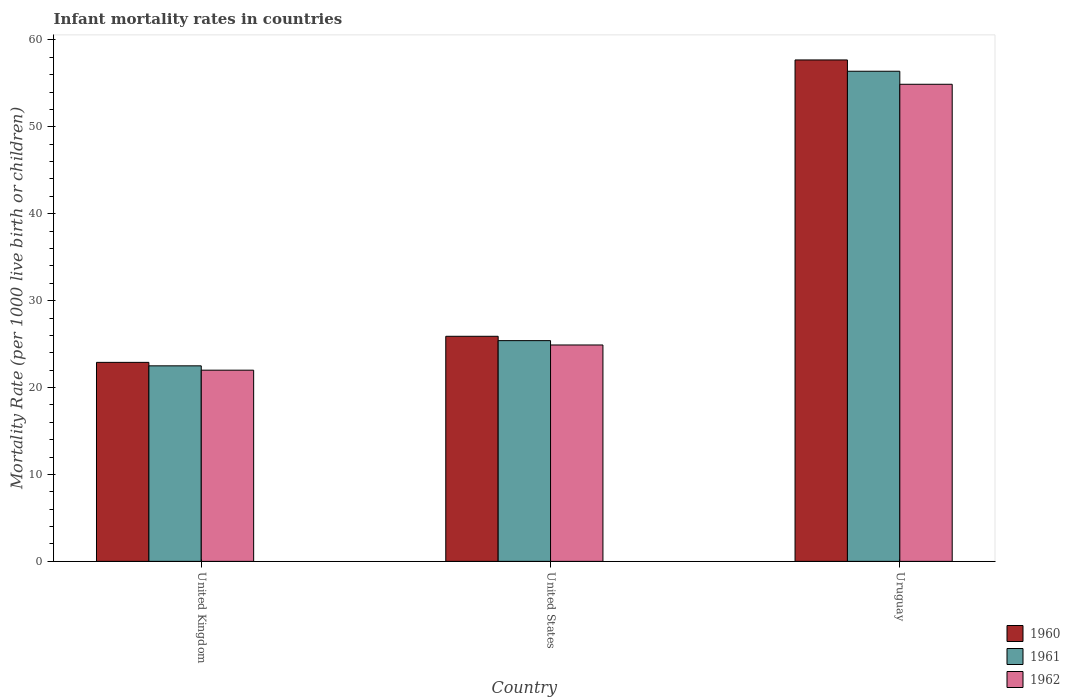Are the number of bars per tick equal to the number of legend labels?
Give a very brief answer. Yes. Are the number of bars on each tick of the X-axis equal?
Your answer should be very brief. Yes. How many bars are there on the 1st tick from the left?
Your answer should be compact. 3. What is the label of the 2nd group of bars from the left?
Offer a very short reply. United States. In how many cases, is the number of bars for a given country not equal to the number of legend labels?
Provide a short and direct response. 0. What is the infant mortality rate in 1962 in United States?
Offer a very short reply. 24.9. Across all countries, what is the maximum infant mortality rate in 1961?
Provide a short and direct response. 56.4. In which country was the infant mortality rate in 1960 maximum?
Provide a short and direct response. Uruguay. What is the total infant mortality rate in 1962 in the graph?
Your answer should be compact. 101.8. What is the difference between the infant mortality rate in 1960 in United States and that in Uruguay?
Make the answer very short. -31.8. What is the difference between the infant mortality rate in 1961 in Uruguay and the infant mortality rate in 1962 in United States?
Keep it short and to the point. 31.5. What is the average infant mortality rate in 1962 per country?
Provide a short and direct response. 33.93. What is the ratio of the infant mortality rate in 1960 in United States to that in Uruguay?
Give a very brief answer. 0.45. Is the infant mortality rate in 1961 in United States less than that in Uruguay?
Ensure brevity in your answer.  Yes. What is the difference between the highest and the second highest infant mortality rate in 1961?
Offer a very short reply. 31. What is the difference between the highest and the lowest infant mortality rate in 1961?
Provide a succinct answer. 33.9. In how many countries, is the infant mortality rate in 1960 greater than the average infant mortality rate in 1960 taken over all countries?
Give a very brief answer. 1. Are all the bars in the graph horizontal?
Make the answer very short. No. Does the graph contain any zero values?
Ensure brevity in your answer.  No. Where does the legend appear in the graph?
Provide a short and direct response. Bottom right. How are the legend labels stacked?
Provide a succinct answer. Vertical. What is the title of the graph?
Your answer should be very brief. Infant mortality rates in countries. Does "1989" appear as one of the legend labels in the graph?
Offer a very short reply. No. What is the label or title of the Y-axis?
Offer a very short reply. Mortality Rate (per 1000 live birth or children). What is the Mortality Rate (per 1000 live birth or children) in 1960 in United Kingdom?
Keep it short and to the point. 22.9. What is the Mortality Rate (per 1000 live birth or children) in 1961 in United Kingdom?
Your answer should be very brief. 22.5. What is the Mortality Rate (per 1000 live birth or children) of 1962 in United Kingdom?
Ensure brevity in your answer.  22. What is the Mortality Rate (per 1000 live birth or children) of 1960 in United States?
Your response must be concise. 25.9. What is the Mortality Rate (per 1000 live birth or children) in 1961 in United States?
Offer a very short reply. 25.4. What is the Mortality Rate (per 1000 live birth or children) of 1962 in United States?
Keep it short and to the point. 24.9. What is the Mortality Rate (per 1000 live birth or children) of 1960 in Uruguay?
Keep it short and to the point. 57.7. What is the Mortality Rate (per 1000 live birth or children) in 1961 in Uruguay?
Your answer should be compact. 56.4. What is the Mortality Rate (per 1000 live birth or children) in 1962 in Uruguay?
Provide a succinct answer. 54.9. Across all countries, what is the maximum Mortality Rate (per 1000 live birth or children) of 1960?
Provide a succinct answer. 57.7. Across all countries, what is the maximum Mortality Rate (per 1000 live birth or children) of 1961?
Your answer should be compact. 56.4. Across all countries, what is the maximum Mortality Rate (per 1000 live birth or children) of 1962?
Your answer should be compact. 54.9. Across all countries, what is the minimum Mortality Rate (per 1000 live birth or children) of 1960?
Your response must be concise. 22.9. Across all countries, what is the minimum Mortality Rate (per 1000 live birth or children) in 1961?
Keep it short and to the point. 22.5. Across all countries, what is the minimum Mortality Rate (per 1000 live birth or children) of 1962?
Your answer should be compact. 22. What is the total Mortality Rate (per 1000 live birth or children) in 1960 in the graph?
Keep it short and to the point. 106.5. What is the total Mortality Rate (per 1000 live birth or children) of 1961 in the graph?
Make the answer very short. 104.3. What is the total Mortality Rate (per 1000 live birth or children) in 1962 in the graph?
Provide a succinct answer. 101.8. What is the difference between the Mortality Rate (per 1000 live birth or children) of 1960 in United Kingdom and that in United States?
Provide a succinct answer. -3. What is the difference between the Mortality Rate (per 1000 live birth or children) in 1962 in United Kingdom and that in United States?
Provide a succinct answer. -2.9. What is the difference between the Mortality Rate (per 1000 live birth or children) in 1960 in United Kingdom and that in Uruguay?
Keep it short and to the point. -34.8. What is the difference between the Mortality Rate (per 1000 live birth or children) of 1961 in United Kingdom and that in Uruguay?
Ensure brevity in your answer.  -33.9. What is the difference between the Mortality Rate (per 1000 live birth or children) of 1962 in United Kingdom and that in Uruguay?
Your response must be concise. -32.9. What is the difference between the Mortality Rate (per 1000 live birth or children) in 1960 in United States and that in Uruguay?
Give a very brief answer. -31.8. What is the difference between the Mortality Rate (per 1000 live birth or children) in 1961 in United States and that in Uruguay?
Offer a terse response. -31. What is the difference between the Mortality Rate (per 1000 live birth or children) in 1960 in United Kingdom and the Mortality Rate (per 1000 live birth or children) in 1961 in United States?
Provide a short and direct response. -2.5. What is the difference between the Mortality Rate (per 1000 live birth or children) in 1961 in United Kingdom and the Mortality Rate (per 1000 live birth or children) in 1962 in United States?
Your answer should be compact. -2.4. What is the difference between the Mortality Rate (per 1000 live birth or children) of 1960 in United Kingdom and the Mortality Rate (per 1000 live birth or children) of 1961 in Uruguay?
Ensure brevity in your answer.  -33.5. What is the difference between the Mortality Rate (per 1000 live birth or children) in 1960 in United Kingdom and the Mortality Rate (per 1000 live birth or children) in 1962 in Uruguay?
Ensure brevity in your answer.  -32. What is the difference between the Mortality Rate (per 1000 live birth or children) in 1961 in United Kingdom and the Mortality Rate (per 1000 live birth or children) in 1962 in Uruguay?
Offer a terse response. -32.4. What is the difference between the Mortality Rate (per 1000 live birth or children) in 1960 in United States and the Mortality Rate (per 1000 live birth or children) in 1961 in Uruguay?
Your answer should be very brief. -30.5. What is the difference between the Mortality Rate (per 1000 live birth or children) of 1960 in United States and the Mortality Rate (per 1000 live birth or children) of 1962 in Uruguay?
Provide a succinct answer. -29. What is the difference between the Mortality Rate (per 1000 live birth or children) of 1961 in United States and the Mortality Rate (per 1000 live birth or children) of 1962 in Uruguay?
Provide a succinct answer. -29.5. What is the average Mortality Rate (per 1000 live birth or children) of 1960 per country?
Your answer should be very brief. 35.5. What is the average Mortality Rate (per 1000 live birth or children) in 1961 per country?
Offer a terse response. 34.77. What is the average Mortality Rate (per 1000 live birth or children) in 1962 per country?
Keep it short and to the point. 33.93. What is the difference between the Mortality Rate (per 1000 live birth or children) in 1960 and Mortality Rate (per 1000 live birth or children) in 1961 in United Kingdom?
Offer a terse response. 0.4. What is the difference between the Mortality Rate (per 1000 live birth or children) in 1961 and Mortality Rate (per 1000 live birth or children) in 1962 in United Kingdom?
Keep it short and to the point. 0.5. What is the difference between the Mortality Rate (per 1000 live birth or children) in 1960 and Mortality Rate (per 1000 live birth or children) in 1961 in United States?
Ensure brevity in your answer.  0.5. What is the difference between the Mortality Rate (per 1000 live birth or children) in 1960 and Mortality Rate (per 1000 live birth or children) in 1961 in Uruguay?
Provide a short and direct response. 1.3. What is the difference between the Mortality Rate (per 1000 live birth or children) of 1960 and Mortality Rate (per 1000 live birth or children) of 1962 in Uruguay?
Offer a very short reply. 2.8. What is the difference between the Mortality Rate (per 1000 live birth or children) of 1961 and Mortality Rate (per 1000 live birth or children) of 1962 in Uruguay?
Provide a succinct answer. 1.5. What is the ratio of the Mortality Rate (per 1000 live birth or children) of 1960 in United Kingdom to that in United States?
Keep it short and to the point. 0.88. What is the ratio of the Mortality Rate (per 1000 live birth or children) in 1961 in United Kingdom to that in United States?
Make the answer very short. 0.89. What is the ratio of the Mortality Rate (per 1000 live birth or children) in 1962 in United Kingdom to that in United States?
Ensure brevity in your answer.  0.88. What is the ratio of the Mortality Rate (per 1000 live birth or children) of 1960 in United Kingdom to that in Uruguay?
Offer a terse response. 0.4. What is the ratio of the Mortality Rate (per 1000 live birth or children) in 1961 in United Kingdom to that in Uruguay?
Provide a succinct answer. 0.4. What is the ratio of the Mortality Rate (per 1000 live birth or children) in 1962 in United Kingdom to that in Uruguay?
Your answer should be very brief. 0.4. What is the ratio of the Mortality Rate (per 1000 live birth or children) of 1960 in United States to that in Uruguay?
Offer a very short reply. 0.45. What is the ratio of the Mortality Rate (per 1000 live birth or children) in 1961 in United States to that in Uruguay?
Give a very brief answer. 0.45. What is the ratio of the Mortality Rate (per 1000 live birth or children) of 1962 in United States to that in Uruguay?
Offer a terse response. 0.45. What is the difference between the highest and the second highest Mortality Rate (per 1000 live birth or children) of 1960?
Keep it short and to the point. 31.8. What is the difference between the highest and the second highest Mortality Rate (per 1000 live birth or children) of 1961?
Provide a succinct answer. 31. What is the difference between the highest and the second highest Mortality Rate (per 1000 live birth or children) of 1962?
Provide a succinct answer. 30. What is the difference between the highest and the lowest Mortality Rate (per 1000 live birth or children) in 1960?
Offer a terse response. 34.8. What is the difference between the highest and the lowest Mortality Rate (per 1000 live birth or children) in 1961?
Provide a short and direct response. 33.9. What is the difference between the highest and the lowest Mortality Rate (per 1000 live birth or children) of 1962?
Your response must be concise. 32.9. 